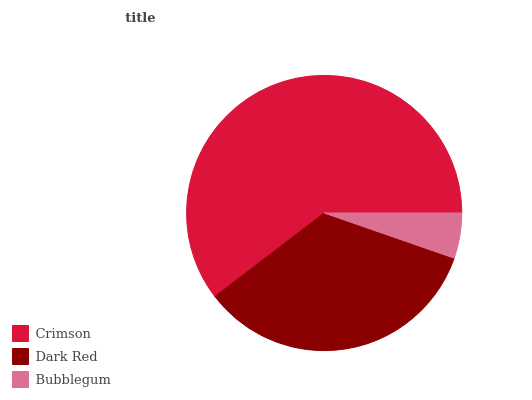Is Bubblegum the minimum?
Answer yes or no. Yes. Is Crimson the maximum?
Answer yes or no. Yes. Is Dark Red the minimum?
Answer yes or no. No. Is Dark Red the maximum?
Answer yes or no. No. Is Crimson greater than Dark Red?
Answer yes or no. Yes. Is Dark Red less than Crimson?
Answer yes or no. Yes. Is Dark Red greater than Crimson?
Answer yes or no. No. Is Crimson less than Dark Red?
Answer yes or no. No. Is Dark Red the high median?
Answer yes or no. Yes. Is Dark Red the low median?
Answer yes or no. Yes. Is Bubblegum the high median?
Answer yes or no. No. Is Bubblegum the low median?
Answer yes or no. No. 